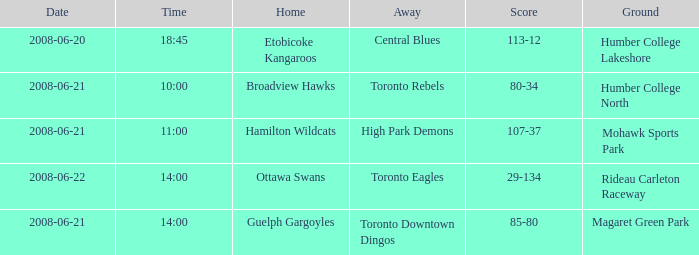What is the Time with a Ground that is humber college north? 10:00. 